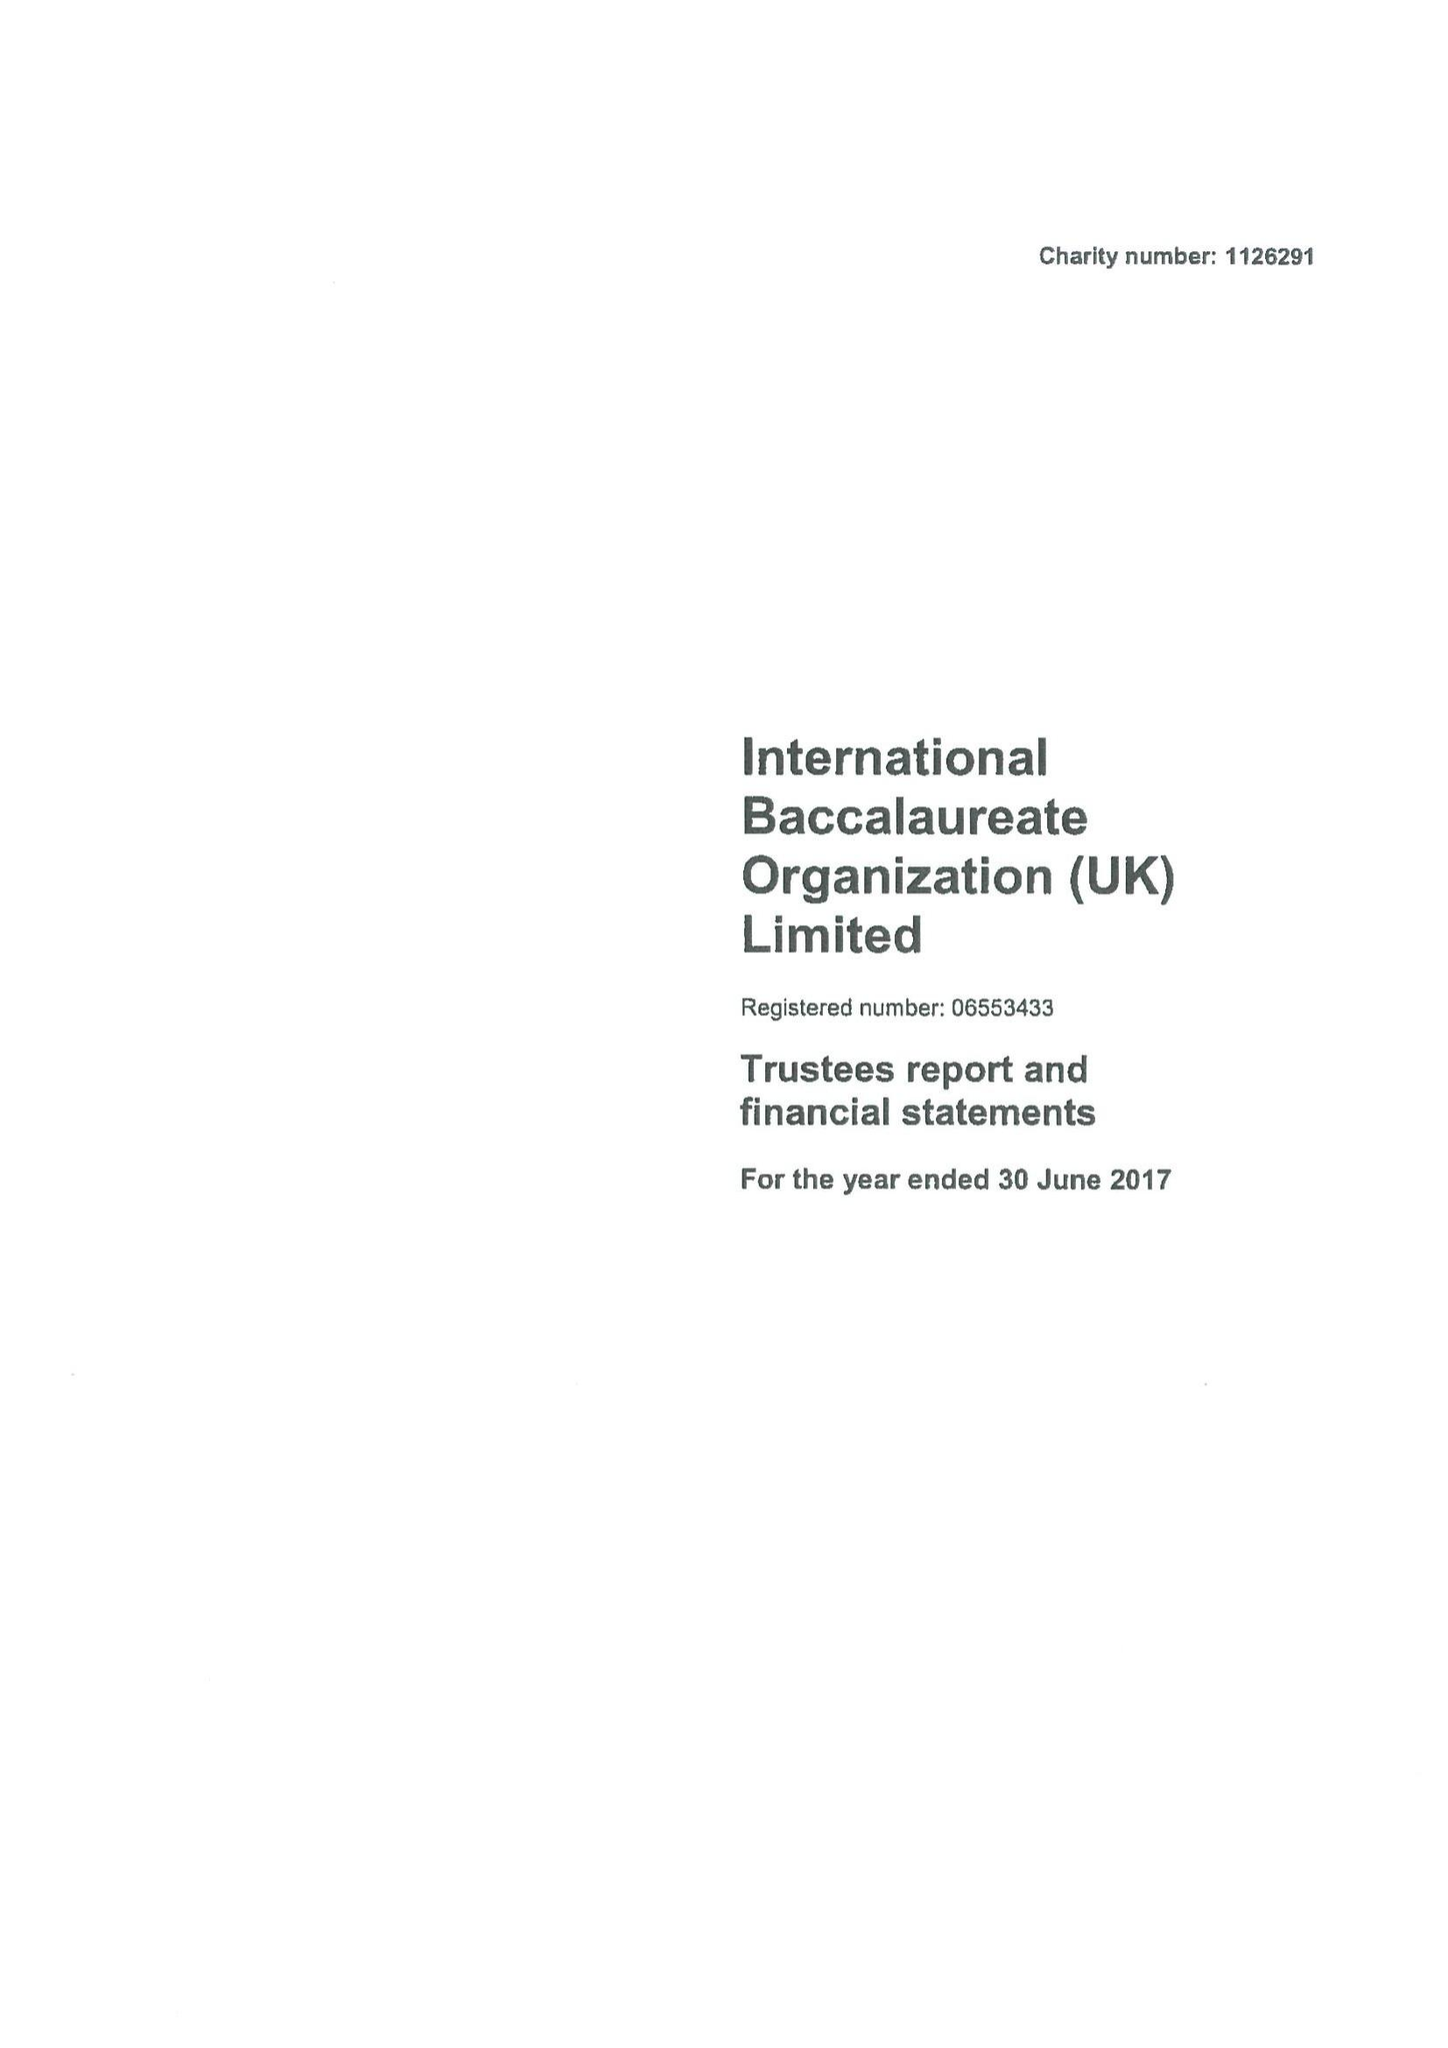What is the value for the income_annually_in_british_pounds?
Answer the question using a single word or phrase. 18382300.00 